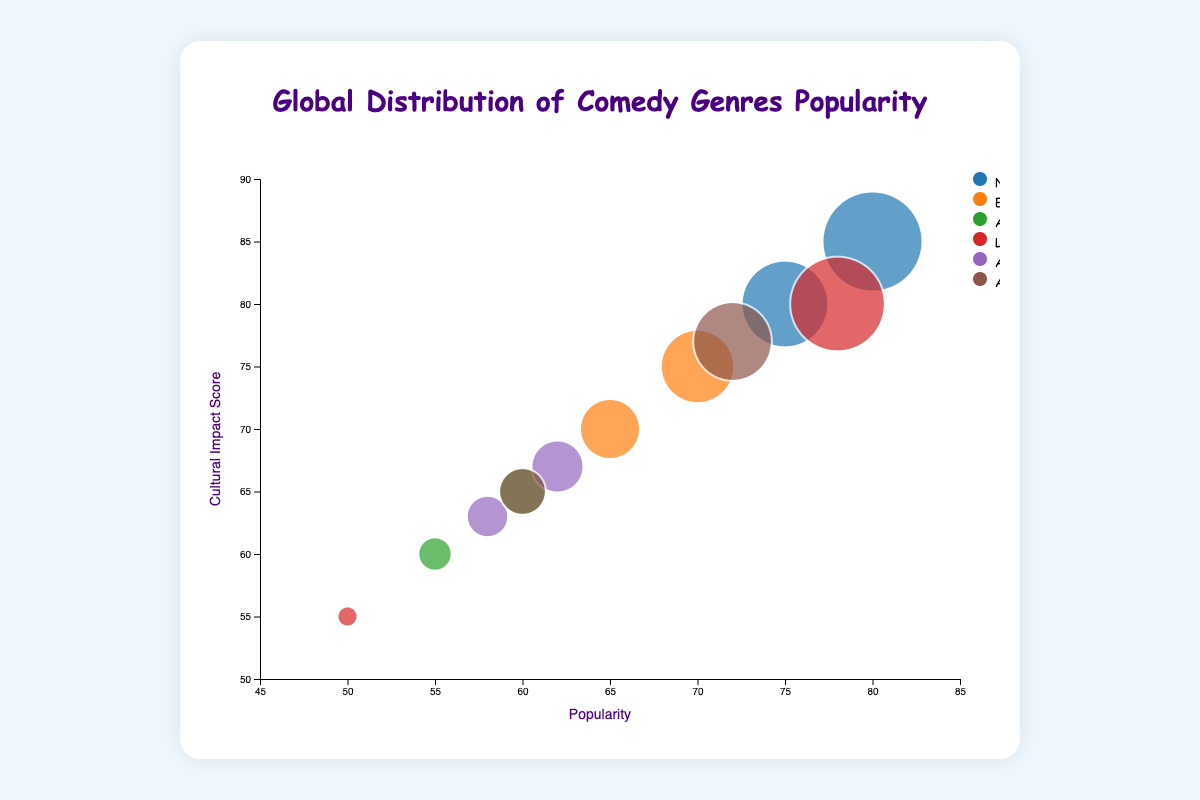What's the title of the figure? The title is generally found at the top of the chart, giving an overview of what the chart represents.
Answer: Global Distribution of Comedy Genres Popularity What are the x and y axes representing? The axes labels are usually displayed along the axes; the x-axis shows "Popularity" and the y-axis shows "Cultural Impact Score".
Answer: Popularity (x-axis) and Cultural Impact Score (y-axis) How many different regions are represented in the chart? The legend at the side of the chart lists all the regions represented; each unique color corresponds to a different region.
Answer: 6 Which genre of comedy has the highest popularity in North America? For North America, look for the largest bubble along the 'Popularity' axis within the "North America" color category.
Answer: Stand-up What genre in Latin America has a higher cultural impact score, Stand-up or Telenovela Comedy? Compare the y-axis positions of the bubbles for both genres under Latin America's color. Telenovela Comedy with a score of 80 is higher than Stand-up with a score of 55.
Answer: Telenovela Comedy Which region has the genre with the highest popularity? Identify the bubble with the highest x-axis value and note the corresponding region color from the legend.
Answer: North America Which genre in Europe has a higher popularity, Stand-up or Slapstick? Check the x-axis positions of the bubbles for both genres under Europe's color. Stand-up has a popularity of 70, while Slapstick has 65.
Answer: Stand-up What is the difference in cultural impact score between Stand-up in North America and Stand-up in Europe? Locate the bubbles for Stand-up in both regions and subtract the y-axis value of Europe from North America's value (85 - 75).
Answer: 10 Which genre in Asia has a lower popularity, Satire or Sketch Comedy? Compare the x-axis positions of the bubbles for both genres under Asia’s color. Satire has a popularity of 55, lower than Sketch Comedy at 60.
Answer: Satire Which region's bubble for Sketch Comedy has a higher cultural impact score, Asia or Africa? Compare the y-axis positions of the bubbles for Sketch Comedy under Asia and Africa's color. Asia's score is 65, higher than Africa's score of 63.
Answer: Asia 